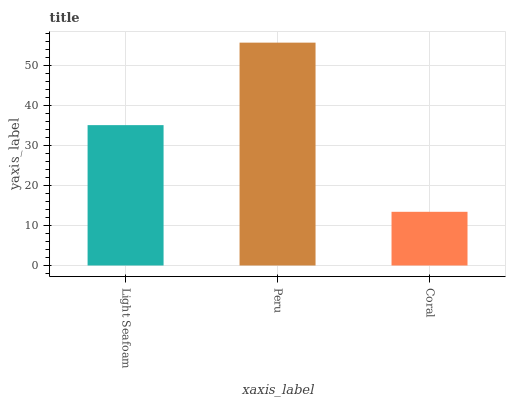Is Coral the minimum?
Answer yes or no. Yes. Is Peru the maximum?
Answer yes or no. Yes. Is Peru the minimum?
Answer yes or no. No. Is Coral the maximum?
Answer yes or no. No. Is Peru greater than Coral?
Answer yes or no. Yes. Is Coral less than Peru?
Answer yes or no. Yes. Is Coral greater than Peru?
Answer yes or no. No. Is Peru less than Coral?
Answer yes or no. No. Is Light Seafoam the high median?
Answer yes or no. Yes. Is Light Seafoam the low median?
Answer yes or no. Yes. Is Coral the high median?
Answer yes or no. No. Is Peru the low median?
Answer yes or no. No. 